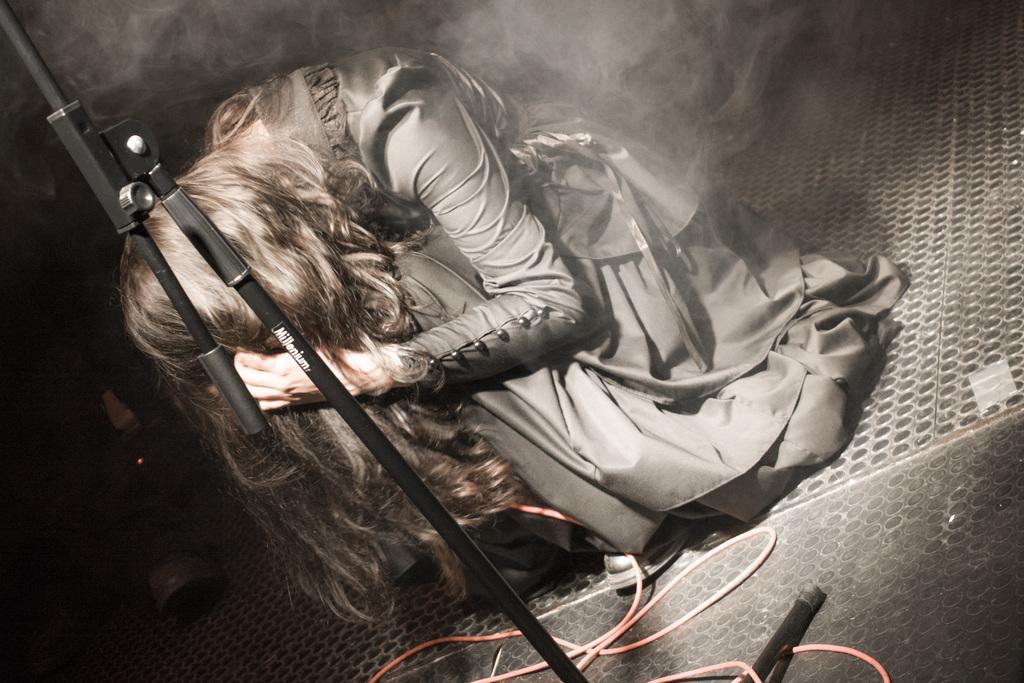Please provide a concise description of this image. In this image there is a girl sitting on a floor, in front of her there is a stand and wire, in the background there is smoke. 